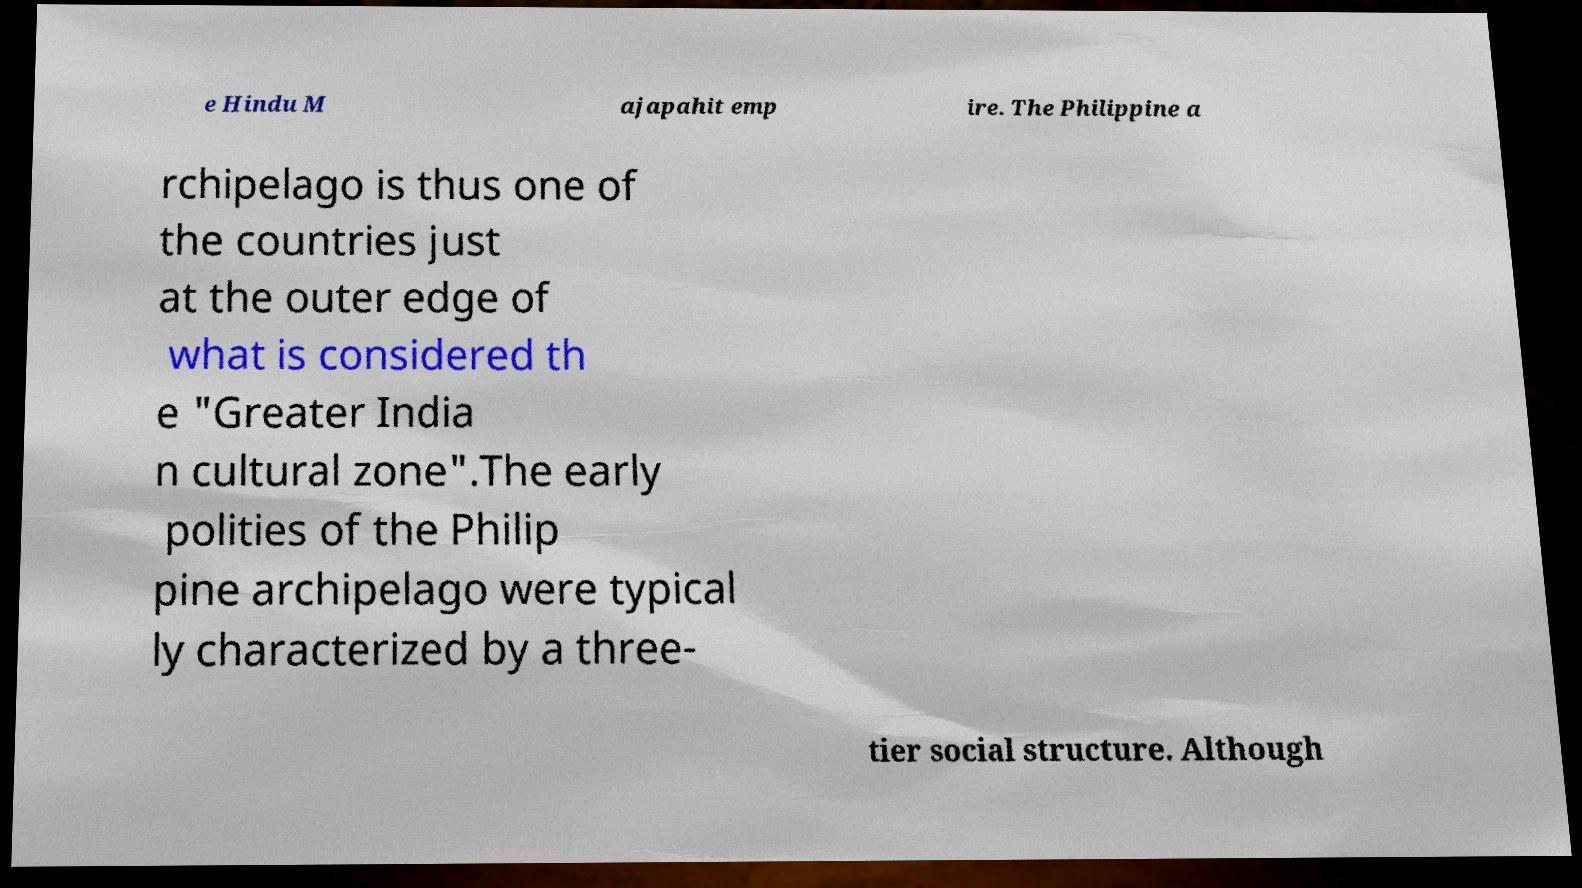Can you read and provide the text displayed in the image?This photo seems to have some interesting text. Can you extract and type it out for me? e Hindu M ajapahit emp ire. The Philippine a rchipelago is thus one of the countries just at the outer edge of what is considered th e "Greater India n cultural zone".The early polities of the Philip pine archipelago were typical ly characterized by a three- tier social structure. Although 